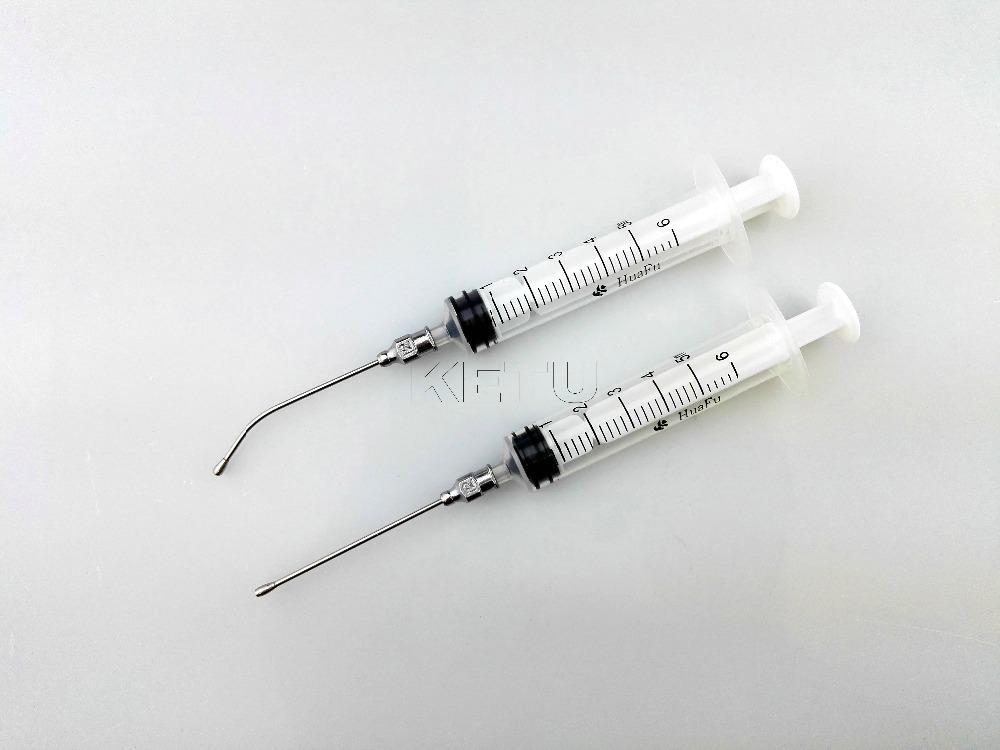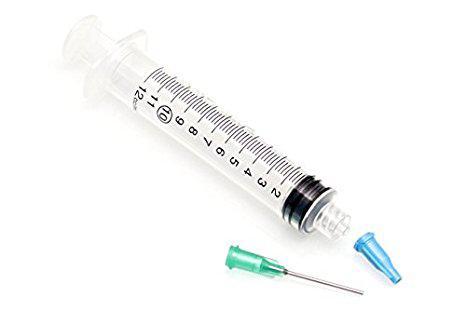The first image is the image on the left, the second image is the image on the right. Evaluate the accuracy of this statement regarding the images: "One of the images shows a single syringe and another image shows two syringes that are parallel to one another.". Is it true? Answer yes or no. Yes. 